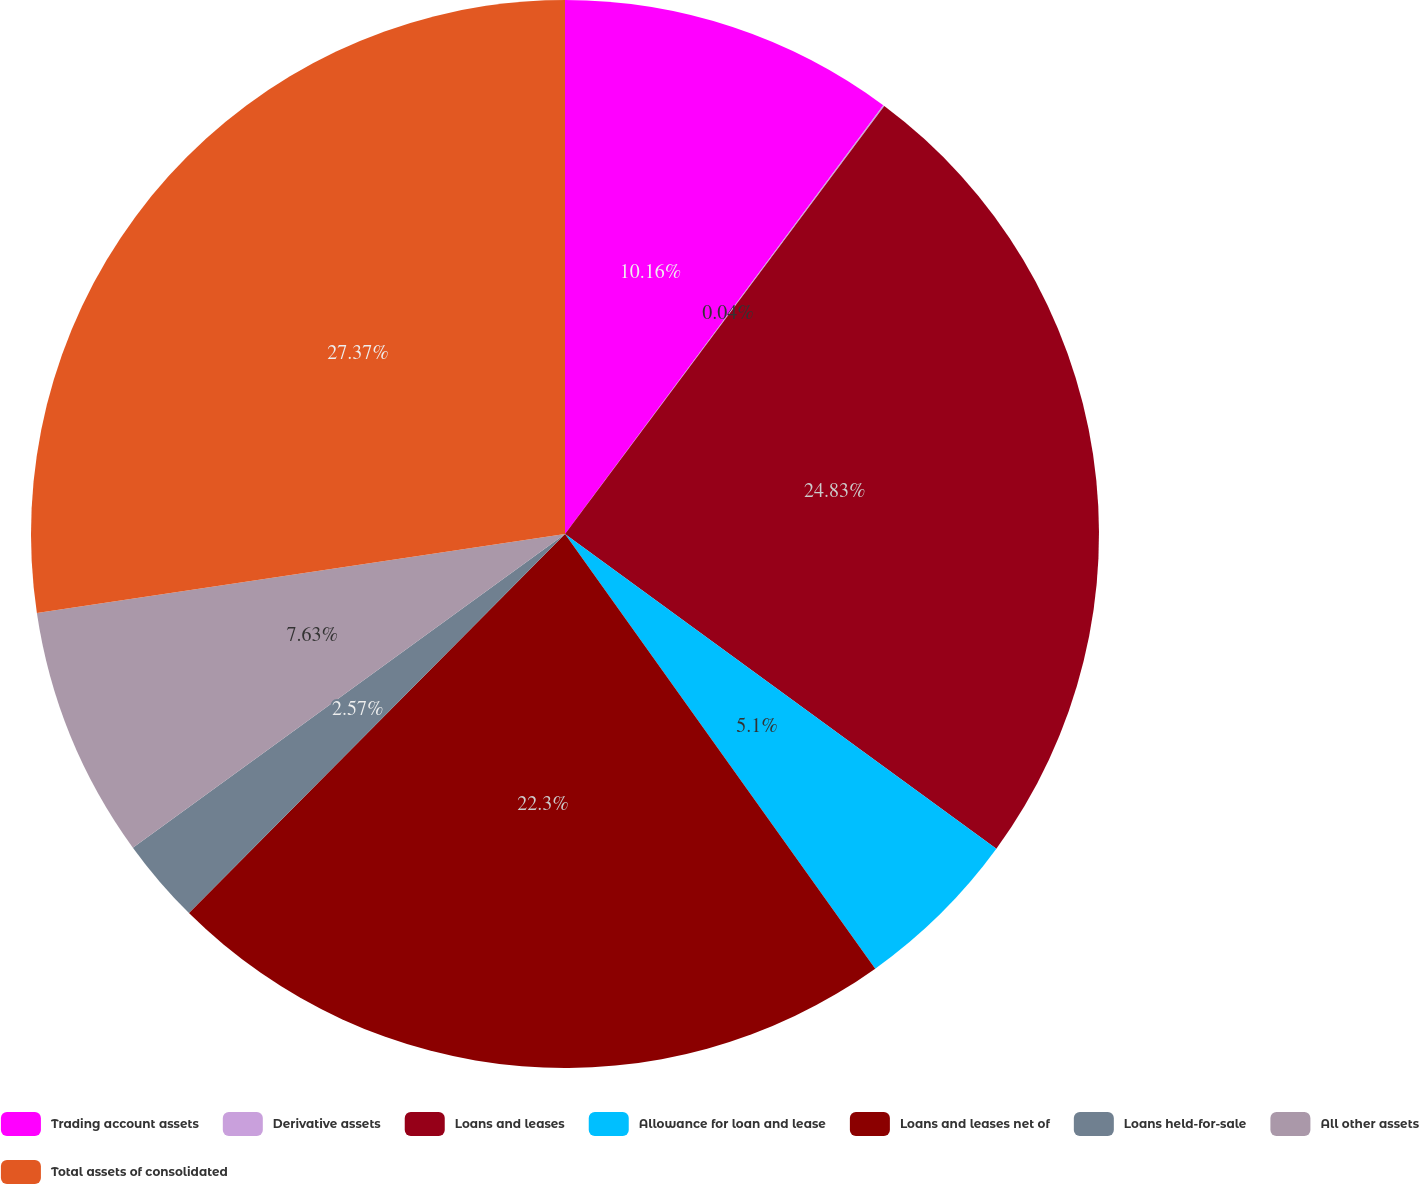Convert chart to OTSL. <chart><loc_0><loc_0><loc_500><loc_500><pie_chart><fcel>Trading account assets<fcel>Derivative assets<fcel>Loans and leases<fcel>Allowance for loan and lease<fcel>Loans and leases net of<fcel>Loans held-for-sale<fcel>All other assets<fcel>Total assets of consolidated<nl><fcel>10.16%<fcel>0.04%<fcel>24.83%<fcel>5.1%<fcel>22.3%<fcel>2.57%<fcel>7.63%<fcel>27.36%<nl></chart> 